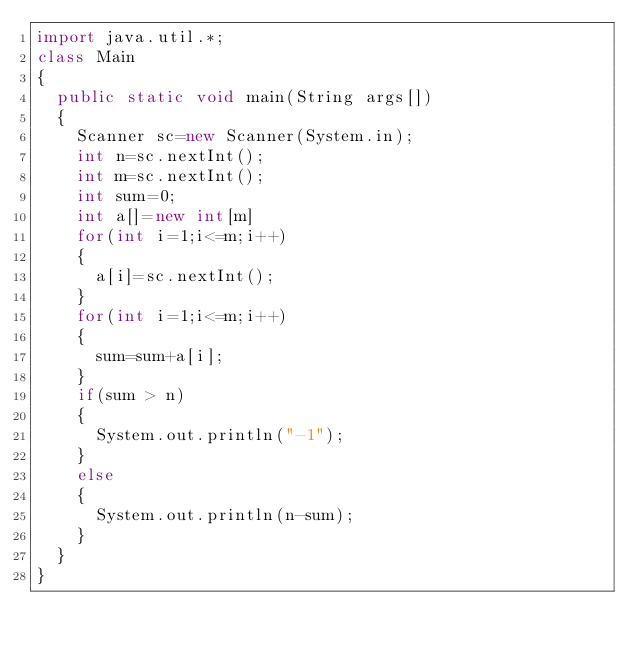<code> <loc_0><loc_0><loc_500><loc_500><_Java_>import java.util.*;
class Main
{
  public static void main(String args[])
  {
    Scanner sc=new Scanner(System.in);
    int n=sc.nextInt();
    int m=sc.nextInt();
    int sum=0;
    int a[]=new int[m]
    for(int i=1;i<=m;i++)
    {
      a[i]=sc.nextInt();
    }
    for(int i=1;i<=m;i++)
    {
      sum=sum+a[i];
    }
    if(sum > n)
    {
      System.out.println("-1");
    }
    else
    {
      System.out.println(n-sum);
    }
  }
}
      
    </code> 